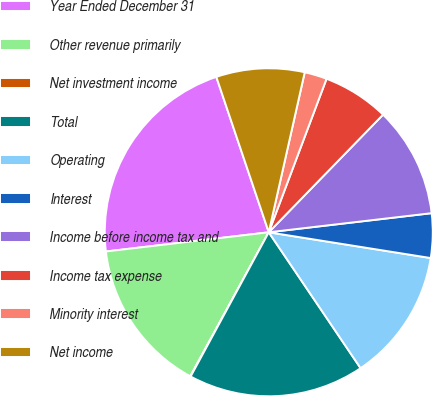Convert chart. <chart><loc_0><loc_0><loc_500><loc_500><pie_chart><fcel>Year Ended December 31<fcel>Other revenue primarily<fcel>Net investment income<fcel>Total<fcel>Operating<fcel>Interest<fcel>Income before income tax and<fcel>Income tax expense<fcel>Minority interest<fcel>Net income<nl><fcel>21.69%<fcel>15.19%<fcel>0.04%<fcel>17.36%<fcel>13.03%<fcel>4.37%<fcel>10.87%<fcel>6.54%<fcel>2.21%<fcel>8.7%<nl></chart> 